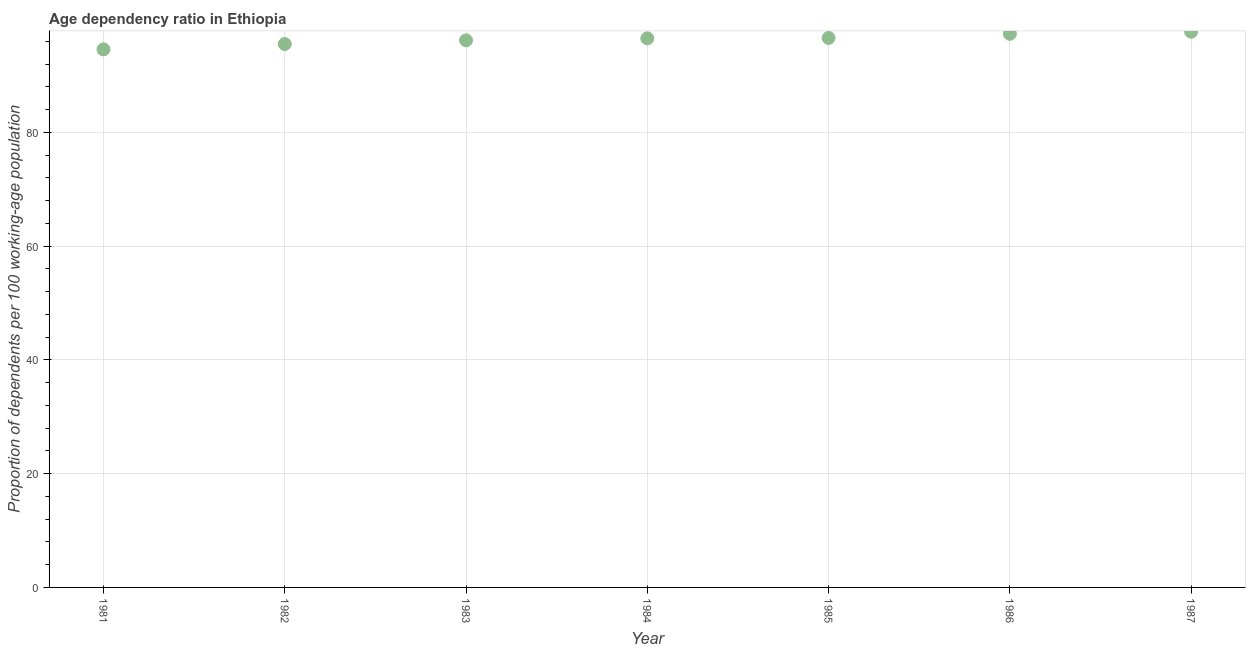What is the age dependency ratio in 1983?
Keep it short and to the point. 96.18. Across all years, what is the maximum age dependency ratio?
Keep it short and to the point. 97.69. Across all years, what is the minimum age dependency ratio?
Provide a succinct answer. 94.59. In which year was the age dependency ratio minimum?
Your response must be concise. 1981. What is the sum of the age dependency ratio?
Your answer should be compact. 674.44. What is the difference between the age dependency ratio in 1984 and 1985?
Make the answer very short. -0.08. What is the average age dependency ratio per year?
Your answer should be very brief. 96.35. What is the median age dependency ratio?
Your answer should be compact. 96.52. Do a majority of the years between 1987 and 1986 (inclusive) have age dependency ratio greater than 92 ?
Ensure brevity in your answer.  No. What is the ratio of the age dependency ratio in 1981 to that in 1985?
Give a very brief answer. 0.98. What is the difference between the highest and the second highest age dependency ratio?
Provide a short and direct response. 0.37. What is the difference between the highest and the lowest age dependency ratio?
Ensure brevity in your answer.  3.1. In how many years, is the age dependency ratio greater than the average age dependency ratio taken over all years?
Your response must be concise. 4. Does the age dependency ratio monotonically increase over the years?
Provide a succinct answer. Yes. What is the title of the graph?
Offer a terse response. Age dependency ratio in Ethiopia. What is the label or title of the X-axis?
Give a very brief answer. Year. What is the label or title of the Y-axis?
Offer a terse response. Proportion of dependents per 100 working-age population. What is the Proportion of dependents per 100 working-age population in 1981?
Provide a succinct answer. 94.59. What is the Proportion of dependents per 100 working-age population in 1982?
Ensure brevity in your answer.  95.53. What is the Proportion of dependents per 100 working-age population in 1983?
Provide a short and direct response. 96.18. What is the Proportion of dependents per 100 working-age population in 1984?
Your answer should be very brief. 96.52. What is the Proportion of dependents per 100 working-age population in 1985?
Give a very brief answer. 96.6. What is the Proportion of dependents per 100 working-age population in 1986?
Offer a very short reply. 97.33. What is the Proportion of dependents per 100 working-age population in 1987?
Give a very brief answer. 97.69. What is the difference between the Proportion of dependents per 100 working-age population in 1981 and 1982?
Provide a short and direct response. -0.94. What is the difference between the Proportion of dependents per 100 working-age population in 1981 and 1983?
Offer a very short reply. -1.59. What is the difference between the Proportion of dependents per 100 working-age population in 1981 and 1984?
Give a very brief answer. -1.93. What is the difference between the Proportion of dependents per 100 working-age population in 1981 and 1985?
Ensure brevity in your answer.  -2.01. What is the difference between the Proportion of dependents per 100 working-age population in 1981 and 1986?
Your response must be concise. -2.74. What is the difference between the Proportion of dependents per 100 working-age population in 1981 and 1987?
Make the answer very short. -3.1. What is the difference between the Proportion of dependents per 100 working-age population in 1982 and 1983?
Offer a very short reply. -0.65. What is the difference between the Proportion of dependents per 100 working-age population in 1982 and 1984?
Offer a very short reply. -1. What is the difference between the Proportion of dependents per 100 working-age population in 1982 and 1985?
Offer a very short reply. -1.07. What is the difference between the Proportion of dependents per 100 working-age population in 1982 and 1986?
Ensure brevity in your answer.  -1.8. What is the difference between the Proportion of dependents per 100 working-age population in 1982 and 1987?
Keep it short and to the point. -2.17. What is the difference between the Proportion of dependents per 100 working-age population in 1983 and 1984?
Provide a succinct answer. -0.35. What is the difference between the Proportion of dependents per 100 working-age population in 1983 and 1985?
Make the answer very short. -0.42. What is the difference between the Proportion of dependents per 100 working-age population in 1983 and 1986?
Offer a terse response. -1.15. What is the difference between the Proportion of dependents per 100 working-age population in 1983 and 1987?
Offer a very short reply. -1.52. What is the difference between the Proportion of dependents per 100 working-age population in 1984 and 1985?
Your answer should be very brief. -0.08. What is the difference between the Proportion of dependents per 100 working-age population in 1984 and 1986?
Offer a terse response. -0.8. What is the difference between the Proportion of dependents per 100 working-age population in 1984 and 1987?
Provide a succinct answer. -1.17. What is the difference between the Proportion of dependents per 100 working-age population in 1985 and 1986?
Ensure brevity in your answer.  -0.73. What is the difference between the Proportion of dependents per 100 working-age population in 1985 and 1987?
Offer a very short reply. -1.09. What is the difference between the Proportion of dependents per 100 working-age population in 1986 and 1987?
Offer a terse response. -0.37. What is the ratio of the Proportion of dependents per 100 working-age population in 1981 to that in 1983?
Your answer should be very brief. 0.98. What is the ratio of the Proportion of dependents per 100 working-age population in 1981 to that in 1984?
Ensure brevity in your answer.  0.98. What is the ratio of the Proportion of dependents per 100 working-age population in 1982 to that in 1984?
Your answer should be very brief. 0.99. What is the ratio of the Proportion of dependents per 100 working-age population in 1982 to that in 1985?
Provide a short and direct response. 0.99. What is the ratio of the Proportion of dependents per 100 working-age population in 1984 to that in 1986?
Provide a short and direct response. 0.99. What is the ratio of the Proportion of dependents per 100 working-age population in 1984 to that in 1987?
Ensure brevity in your answer.  0.99. What is the ratio of the Proportion of dependents per 100 working-age population in 1985 to that in 1987?
Your answer should be compact. 0.99. 